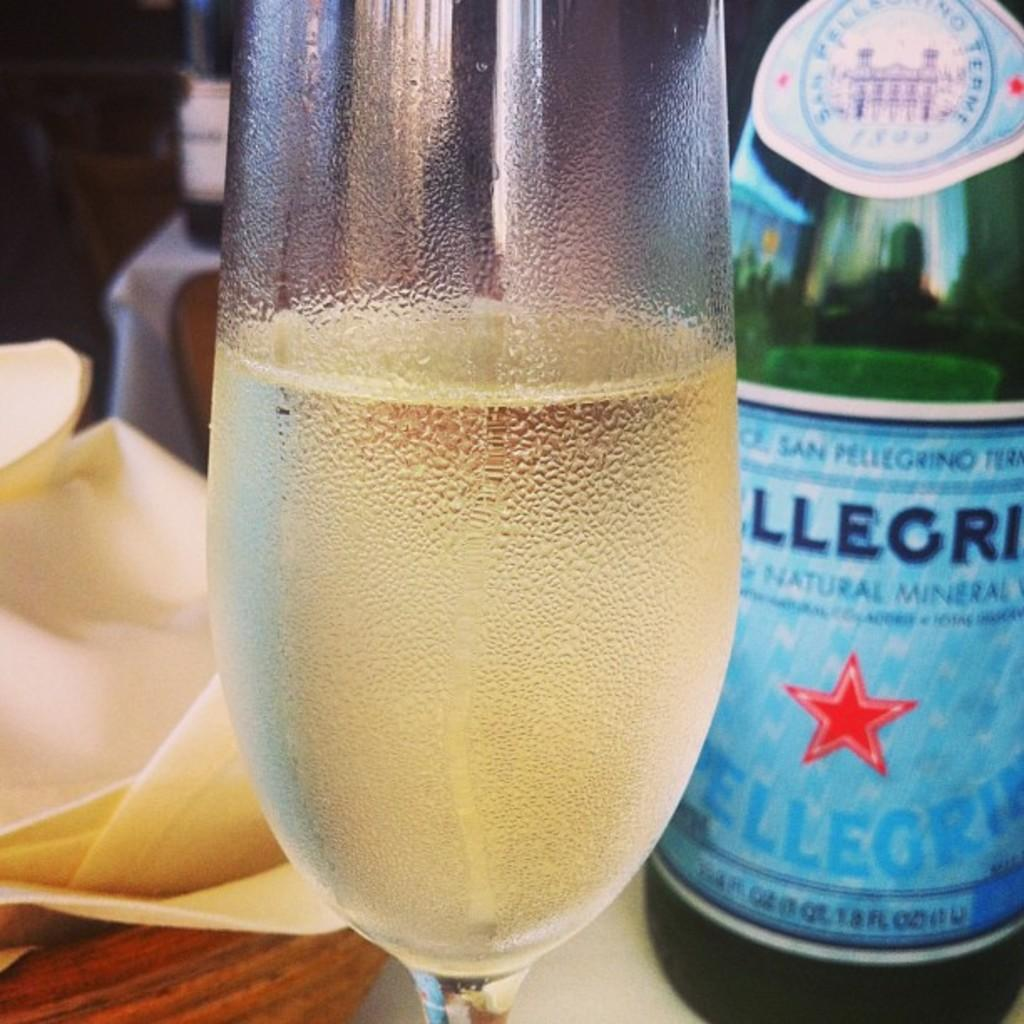<image>
Provide a brief description of the given image. a flute of pellegrio is sitting in front of the bottle that it came from 